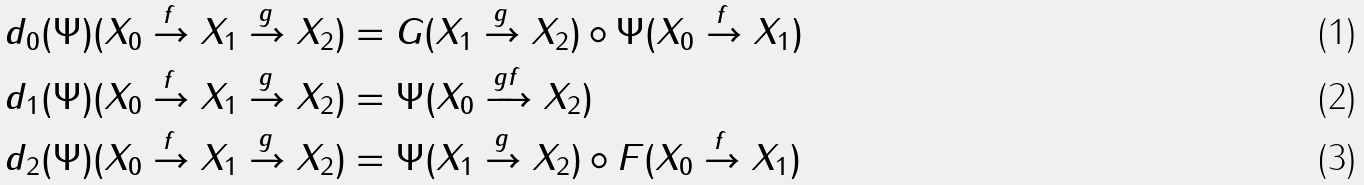Convert formula to latex. <formula><loc_0><loc_0><loc_500><loc_500>\ & d _ { 0 } ( \Psi ) ( X _ { 0 } \xrightarrow { f } X _ { 1 } \xrightarrow { g } X _ { 2 } ) = G ( X _ { 1 } \xrightarrow { g } X _ { 2 } ) \circ \Psi ( X _ { 0 } \xrightarrow { f } X _ { 1 } ) \\ & d _ { 1 } ( \Psi ) ( X _ { 0 } \xrightarrow { f } X _ { 1 } \xrightarrow { g } X _ { 2 } ) = \Psi ( X _ { 0 } \xrightarrow { g f } X _ { 2 } ) \\ & d _ { 2 } ( \Psi ) ( X _ { 0 } \xrightarrow { f } X _ { 1 } \xrightarrow { g } X _ { 2 } ) = \Psi ( X _ { 1 } \xrightarrow { g } X _ { 2 } ) \circ F ( X _ { 0 } \xrightarrow { f } X _ { 1 } )</formula> 